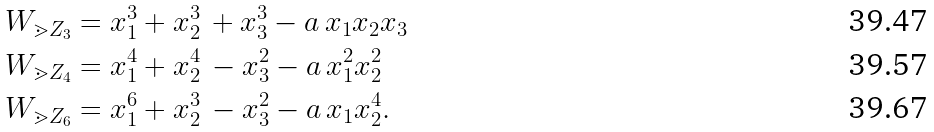Convert formula to latex. <formula><loc_0><loc_0><loc_500><loc_500>W _ { \mathbb { m } { Z } _ { 3 } } & = x _ { 1 } ^ { 3 } + x _ { 2 } ^ { 3 } \, + x _ { 3 } ^ { 3 } - a \, x _ { 1 } x _ { 2 } x _ { 3 } \\ W _ { \mathbb { m } { Z } _ { 4 } } & = x _ { 1 } ^ { 4 } + x _ { 2 } ^ { 4 } \, - x _ { 3 } ^ { 2 } - a \, x _ { 1 } ^ { 2 } x _ { 2 } ^ { 2 } \\ W _ { \mathbb { m } { Z } _ { 6 } } & = x _ { 1 } ^ { 6 } + x _ { 2 } ^ { 3 } \, - x _ { 3 } ^ { 2 } - a \, x _ { 1 } x _ { 2 } ^ { 4 } .</formula> 